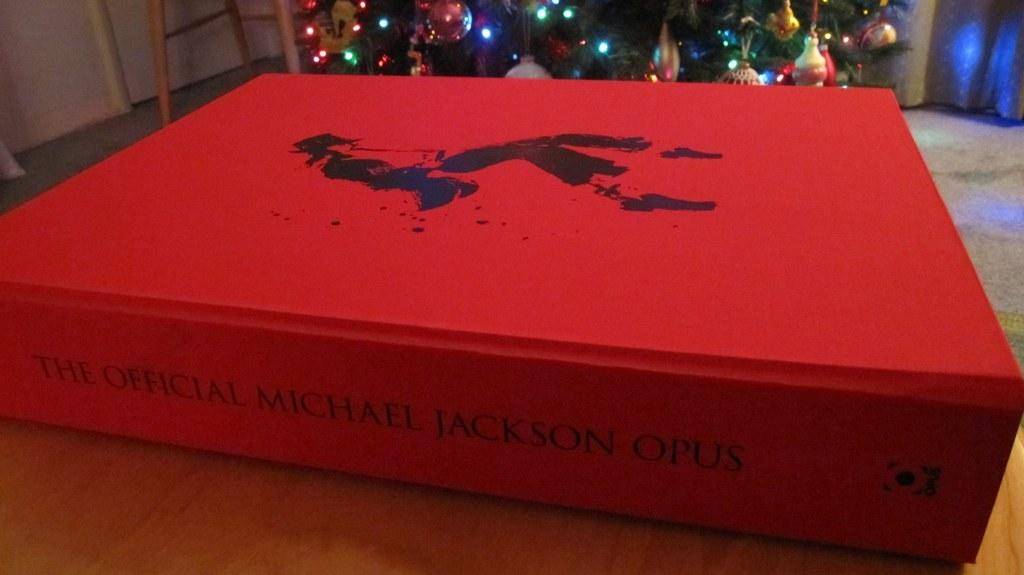<image>
Relay a brief, clear account of the picture shown. A RED HARDVERED BOOK CALLED THE OFFICAL MICHAEL JACKSON OPUS 